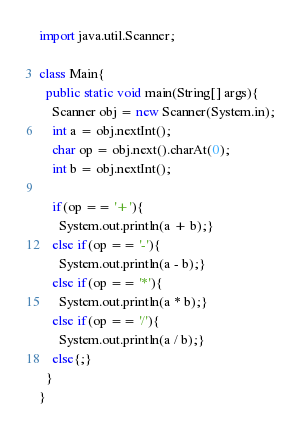<code> <loc_0><loc_0><loc_500><loc_500><_Java_>import java.util.Scanner;

class Main{
  public static void main(String[] args){
    Scanner obj = new Scanner(System.in);
    int a = obj.nextInt();
    char op = obj.next().charAt(0);
    int b = obj.nextInt();
    
    if(op == '+'){
      System.out.println(a + b);}
    else if(op == '-'){
      System.out.println(a - b);}
    else if(op == '*'){
      System.out.println(a * b);}
    else if(op == '/'){
      System.out.println(a / b);}
    else{;}
  }
}</code> 